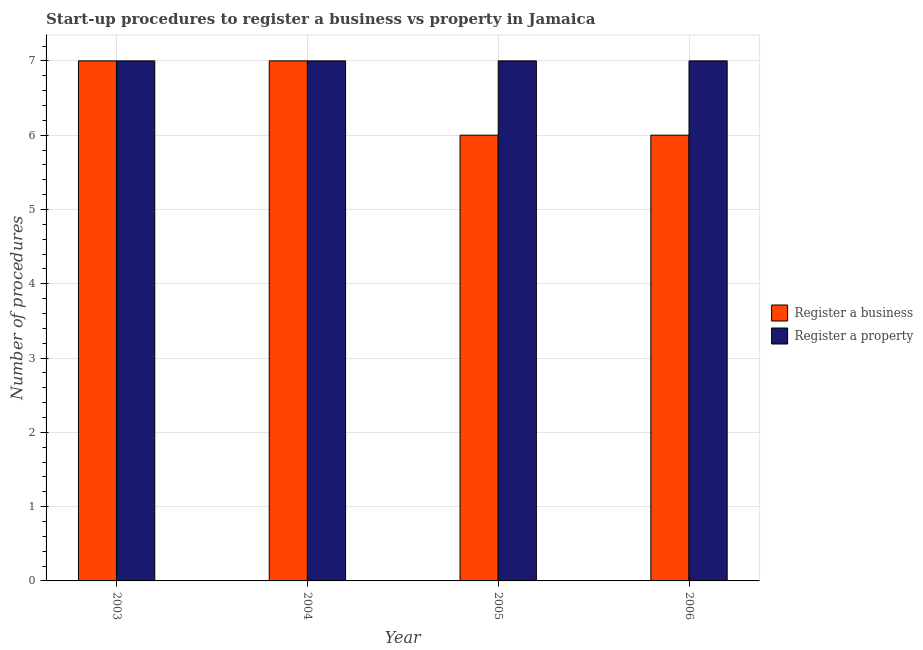How many different coloured bars are there?
Provide a short and direct response. 2. How many groups of bars are there?
Your answer should be compact. 4. Are the number of bars per tick equal to the number of legend labels?
Provide a short and direct response. Yes. Are the number of bars on each tick of the X-axis equal?
Your answer should be compact. Yes. How many bars are there on the 1st tick from the left?
Offer a very short reply. 2. In how many cases, is the number of bars for a given year not equal to the number of legend labels?
Your answer should be very brief. 0. What is the number of procedures to register a property in 2004?
Provide a succinct answer. 7. Across all years, what is the maximum number of procedures to register a business?
Provide a succinct answer. 7. In which year was the number of procedures to register a property maximum?
Your answer should be compact. 2003. What is the total number of procedures to register a business in the graph?
Offer a very short reply. 26. What is the difference between the number of procedures to register a business in 2004 and that in 2006?
Offer a very short reply. 1. What is the average number of procedures to register a property per year?
Your answer should be compact. 7. In the year 2005, what is the difference between the number of procedures to register a business and number of procedures to register a property?
Give a very brief answer. 0. In how many years, is the number of procedures to register a business greater than 5.4?
Make the answer very short. 4. What is the difference between the highest and the lowest number of procedures to register a property?
Offer a terse response. 0. What does the 1st bar from the left in 2005 represents?
Your answer should be compact. Register a business. What does the 2nd bar from the right in 2005 represents?
Provide a short and direct response. Register a business. Are all the bars in the graph horizontal?
Keep it short and to the point. No. What is the difference between two consecutive major ticks on the Y-axis?
Provide a short and direct response. 1. Does the graph contain any zero values?
Provide a short and direct response. No. Does the graph contain grids?
Make the answer very short. Yes. Where does the legend appear in the graph?
Make the answer very short. Center right. How many legend labels are there?
Give a very brief answer. 2. What is the title of the graph?
Offer a terse response. Start-up procedures to register a business vs property in Jamaica. Does "Chemicals" appear as one of the legend labels in the graph?
Your answer should be very brief. No. What is the label or title of the X-axis?
Ensure brevity in your answer.  Year. What is the label or title of the Y-axis?
Your answer should be compact. Number of procedures. What is the Number of procedures of Register a business in 2003?
Your answer should be compact. 7. What is the Number of procedures in Register a business in 2005?
Offer a very short reply. 6. What is the Number of procedures in Register a business in 2006?
Keep it short and to the point. 6. What is the Number of procedures in Register a property in 2006?
Your response must be concise. 7. Across all years, what is the minimum Number of procedures in Register a business?
Keep it short and to the point. 6. Across all years, what is the minimum Number of procedures of Register a property?
Keep it short and to the point. 7. What is the total Number of procedures of Register a property in the graph?
Your answer should be very brief. 28. What is the difference between the Number of procedures of Register a business in 2003 and that in 2004?
Keep it short and to the point. 0. What is the difference between the Number of procedures in Register a business in 2003 and that in 2005?
Your answer should be very brief. 1. What is the difference between the Number of procedures in Register a business in 2003 and that in 2006?
Ensure brevity in your answer.  1. What is the difference between the Number of procedures in Register a property in 2003 and that in 2006?
Make the answer very short. 0. What is the difference between the Number of procedures in Register a property in 2004 and that in 2006?
Offer a very short reply. 0. What is the difference between the Number of procedures in Register a business in 2003 and the Number of procedures in Register a property in 2006?
Provide a succinct answer. 0. What is the difference between the Number of procedures of Register a business in 2004 and the Number of procedures of Register a property in 2006?
Make the answer very short. 0. What is the average Number of procedures in Register a business per year?
Provide a succinct answer. 6.5. What is the average Number of procedures of Register a property per year?
Keep it short and to the point. 7. In the year 2003, what is the difference between the Number of procedures in Register a business and Number of procedures in Register a property?
Provide a succinct answer. 0. In the year 2004, what is the difference between the Number of procedures of Register a business and Number of procedures of Register a property?
Offer a very short reply. 0. What is the ratio of the Number of procedures in Register a property in 2003 to that in 2004?
Provide a succinct answer. 1. What is the ratio of the Number of procedures of Register a business in 2003 to that in 2005?
Your answer should be very brief. 1.17. What is the ratio of the Number of procedures in Register a business in 2004 to that in 2006?
Keep it short and to the point. 1.17. What is the difference between the highest and the second highest Number of procedures of Register a business?
Your answer should be very brief. 0. What is the difference between the highest and the lowest Number of procedures in Register a business?
Your answer should be very brief. 1. What is the difference between the highest and the lowest Number of procedures in Register a property?
Keep it short and to the point. 0. 